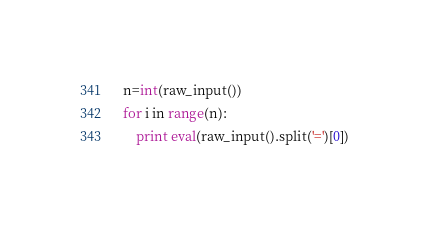<code> <loc_0><loc_0><loc_500><loc_500><_Python_>n=int(raw_input())
for i in range(n):
	print eval(raw_input().split('=')[0])</code> 